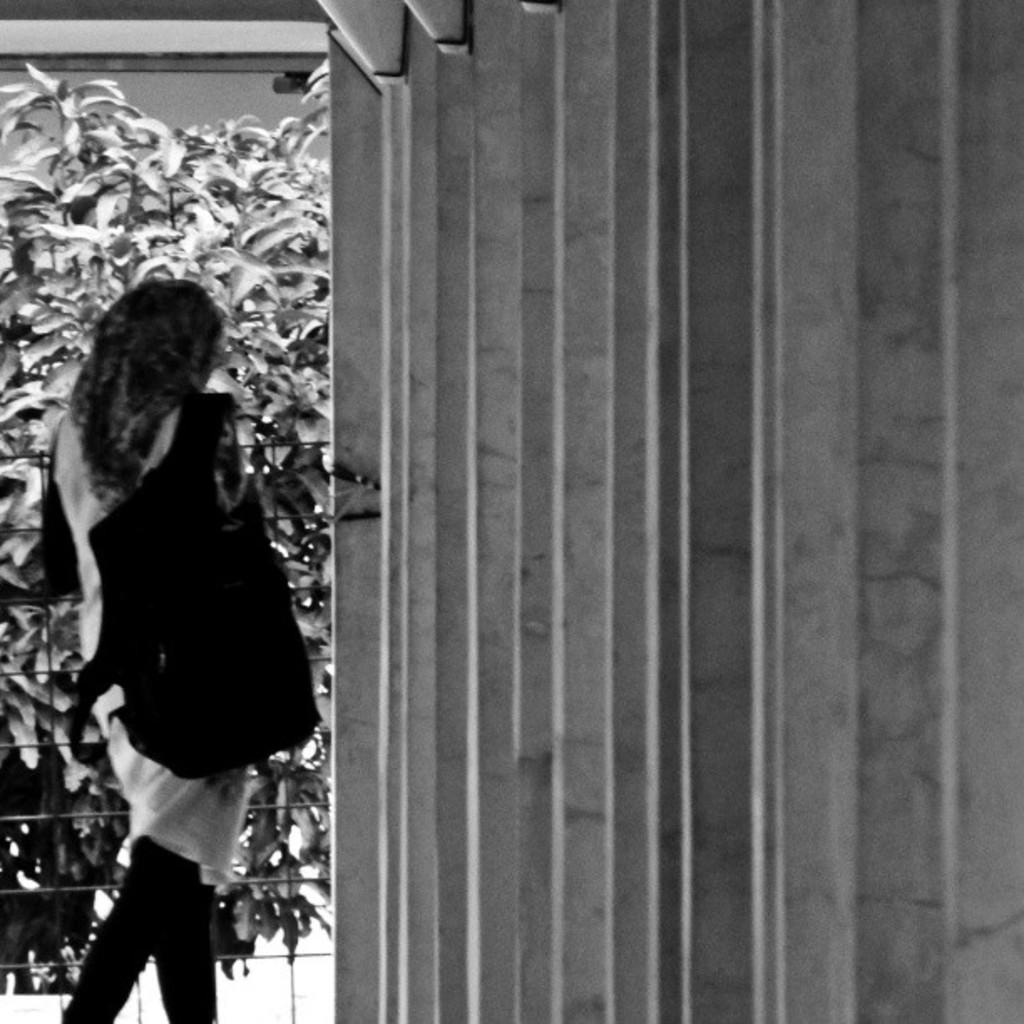What is the color scheme of the image? The image is black and white. Who is present in the image? There is a woman in the image. What is the woman wearing? The woman is wearing a bag. What is the woman doing in the image? The woman is walking. What type of vegetation can be seen in the image? There are plants in the image. What architectural features are present in the image? There is a fence and a wall in the image. What flavor of rabbit can be seen in the image? There is no rabbit present in the image, so it is not possible to determine its flavor. 